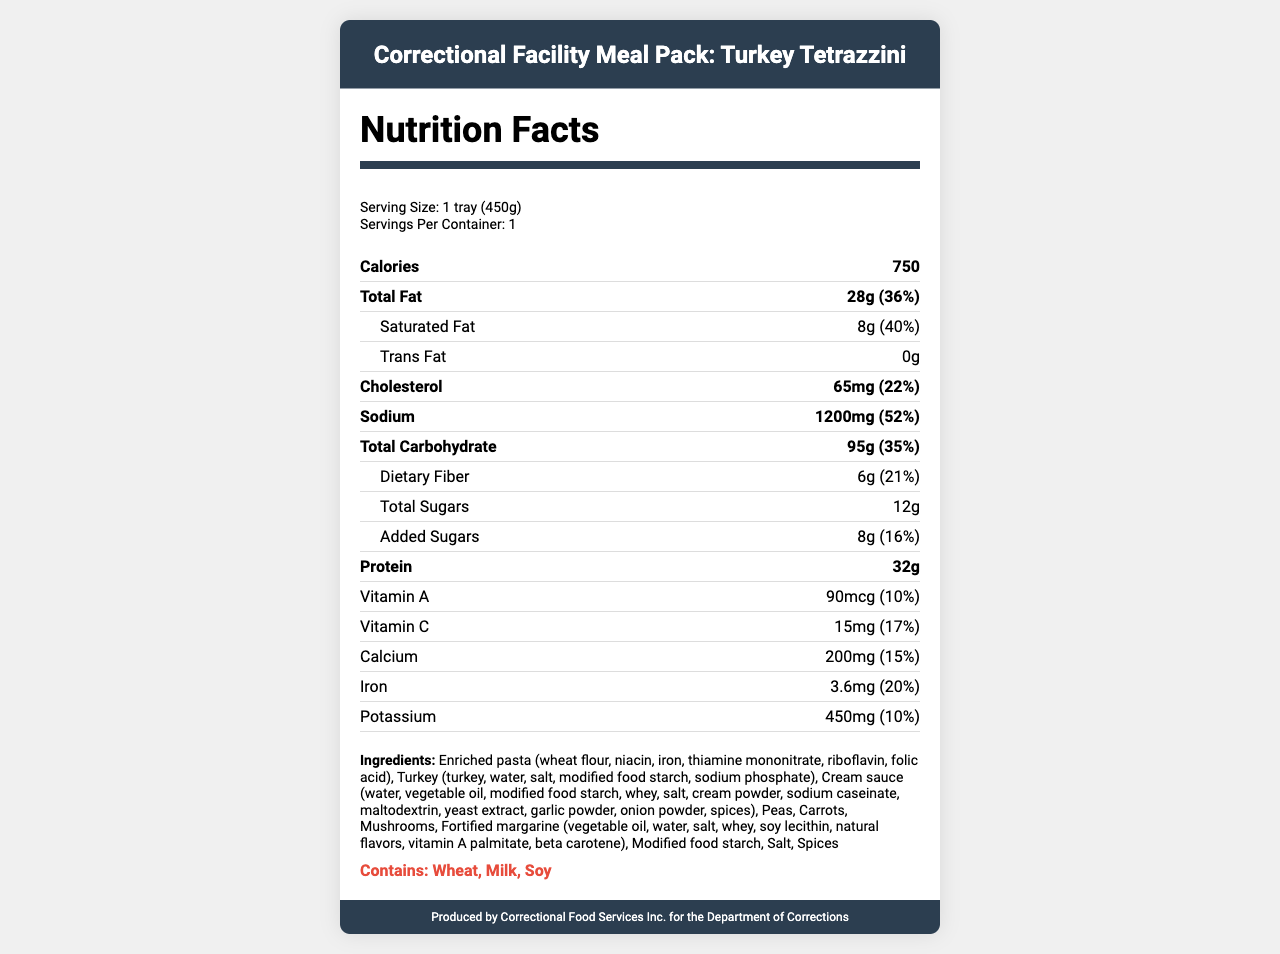what is the serving size of the meal? The serving size is listed as "1 tray (450g)" under the "Nutrition Facts" section.
Answer: 1 tray (450g) how many calories are in one serving? The calories per serving are noted as 750 in the "Nutrition Facts" section.
Answer: 750 what is the percentage of daily value for sodium? The sodium content is listed as 1200 mg with a percent daily value of 52%.
Answer: 52% how much protein is in the meal? The protein content is stated as 32g in the "Nutrition Facts" section.
Answer: 32g what allergens are present in this meal? The allergens section lists "Contains: Wheat, Milk, Soy."
Answer: Wheat, Milk, Soy what is the total fat content? The total fat content is listed as 28g.
Answer: 28g how long is the shelf life of this meal? The shelf life is mentioned as "12 months when stored properly."
Answer: 12 months how much added sugar does the meal contain? The added sugars are listed as 8g with a percent daily value of 16%.
Answer: 8g what kind of meat is used in this meal? A. Chicken B. Beef C. Turkey D. Pork The product name and ingredients list "Turkey" as the main meat component.
Answer: C. Turkey what are the storage instructions for this meal? A. Keep refrigerated B. Keep frozen C. Store at room temperature D. Store in a cool, dry place The storage instructions state "Keep frozen at 0°F (-18°C) or below."
Answer: B. Keep frozen does this meal contain any trans fat? The trans fat content is listed as 0g.
Answer: No does this meal follow the nutritional standards set by the American Correctional Association (ACA)? The document states that the meal "Meets or exceeds the nutritional standards set by the American Correctional Association (ACA)."
Answer: Yes summarize the main idea of this document. The document describes various aspects of the Turkey Tetrazzini meal, such as nutritional information, ingredients, allergens, and manufacturing details, and addresses concerns about its suitability for inmates.
Answer: This document provides a detailed nutritional breakdown of a packaged Turkey Tetrazzini meal commonly served in correctional facilities, including its serving size, caloric content, macronutrients, vitamins, minerals, ingredients, allergens, storage and heating instructions. Additionally, the document highlights concerns regarding high sodium content, limited fresh ingredients, nutritional adequacy, and cost-effectiveness. how much fiber does this meal provide? The dietary fiber content is listed as 6g with a percent daily value of 21%.
Answer: 6g what is the percentage of daily value for cholesterol? The cholesterol content is listed as 65 mg with a percent daily value of 22%.
Answer: 22% can you determine the source of the modified food starch? The document lists "modified food starch" in the ingredients but does not specify its source.
Answer: Not enough information 